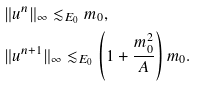<formula> <loc_0><loc_0><loc_500><loc_500>& \| u ^ { n } \| _ { \infty } \lesssim _ { E _ { 0 } } m _ { 0 } , \\ & \| u ^ { n + 1 } \| _ { \infty } \lesssim _ { E _ { 0 } } \left ( 1 + \frac { m _ { 0 } ^ { 2 } } A \right ) m _ { 0 } .</formula> 